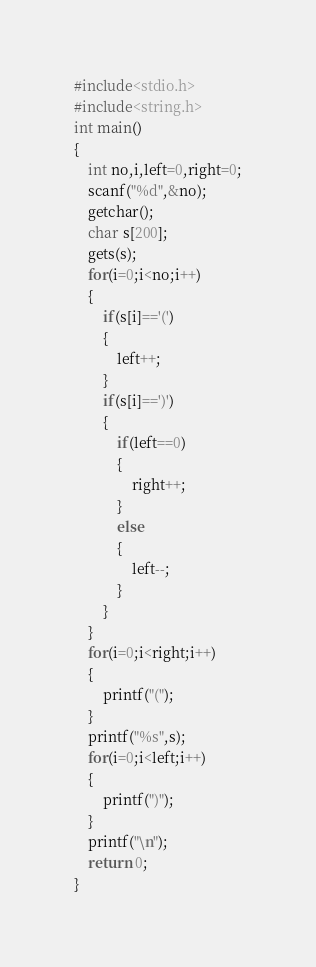<code> <loc_0><loc_0><loc_500><loc_500><_C_>#include<stdio.h>
#include<string.h>
int main()
{
    int no,i,left=0,right=0;
    scanf("%d",&no);
    getchar();
    char s[200];
    gets(s);
    for(i=0;i<no;i++)
    {
        if(s[i]=='(')
        {
            left++;
        }
        if(s[i]==')')
        {
            if(left==0)
            {
                right++;
            }
            else
            {
                left--;
            }
        }
    }
    for(i=0;i<right;i++)
    {
        printf("(");
    }
    printf("%s",s);
    for(i=0;i<left;i++)
    {
        printf(")");
    }
    printf("\n");
    return 0;
}
</code> 